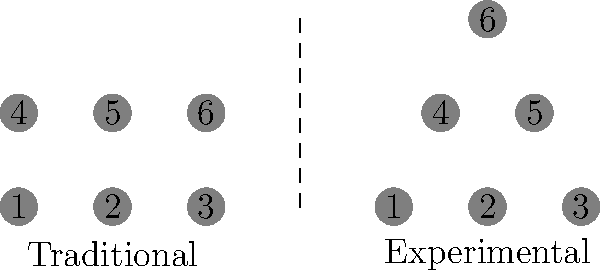Consider the two orchestral seating arrangements shown above, where each numbered circle represents a section of the orchestra. From a topological perspective, are these two arrangements homeomorphic? If so, describe a continuous deformation that transforms one into the other, relating this to the concept of musical texture in film scoring. To determine if the two orchestral seating arrangements are homeomorphic, we need to follow these steps:

1. Analyze the topological properties:
   Both arrangements have 6 sections, maintaining the same number of elements.
   The connectivity between sections is preserved in both arrangements.

2. Identify a continuous deformation:
   We can transform the traditional arrangement into the experimental one by:
   a) Moving sections 4 and 6 upward and inward.
   b) Moving section 5 upward.
   This deformation is continuous and bijective, preserving neighborhoods.

3. Inverse transformation:
   The process can be reversed, transforming the experimental arrangement back to the traditional one.

4. Relation to film scoring texture:
   In film scoring, the transformation between these arrangements can be likened to changing the musical texture:
   a) The traditional arrangement represents a more layered, horizontal texture (like Aaron Copland's "Appalachian Spring").
   b) The experimental arrangement suggests a more vertical, harmonically-focused texture (similar to Copland's "Fanfare for the Common Man").

5. Homeomorphism in music:
   Just as the topological homeomorphism preserves essential properties while allowing for deformation, a film composer can maintain the core musical ideas while adapting the orchestral texture to suit different scenes or emotions.

Therefore, the two arrangements are indeed homeomorphic, as there exists a continuous, bijective function with a continuous inverse that transforms one into the other, while preserving the essential musical relationships between orchestral sections.
Answer: Yes, homeomorphic. Continuous deformation preserves musical relationships while allowing textural transformation. 